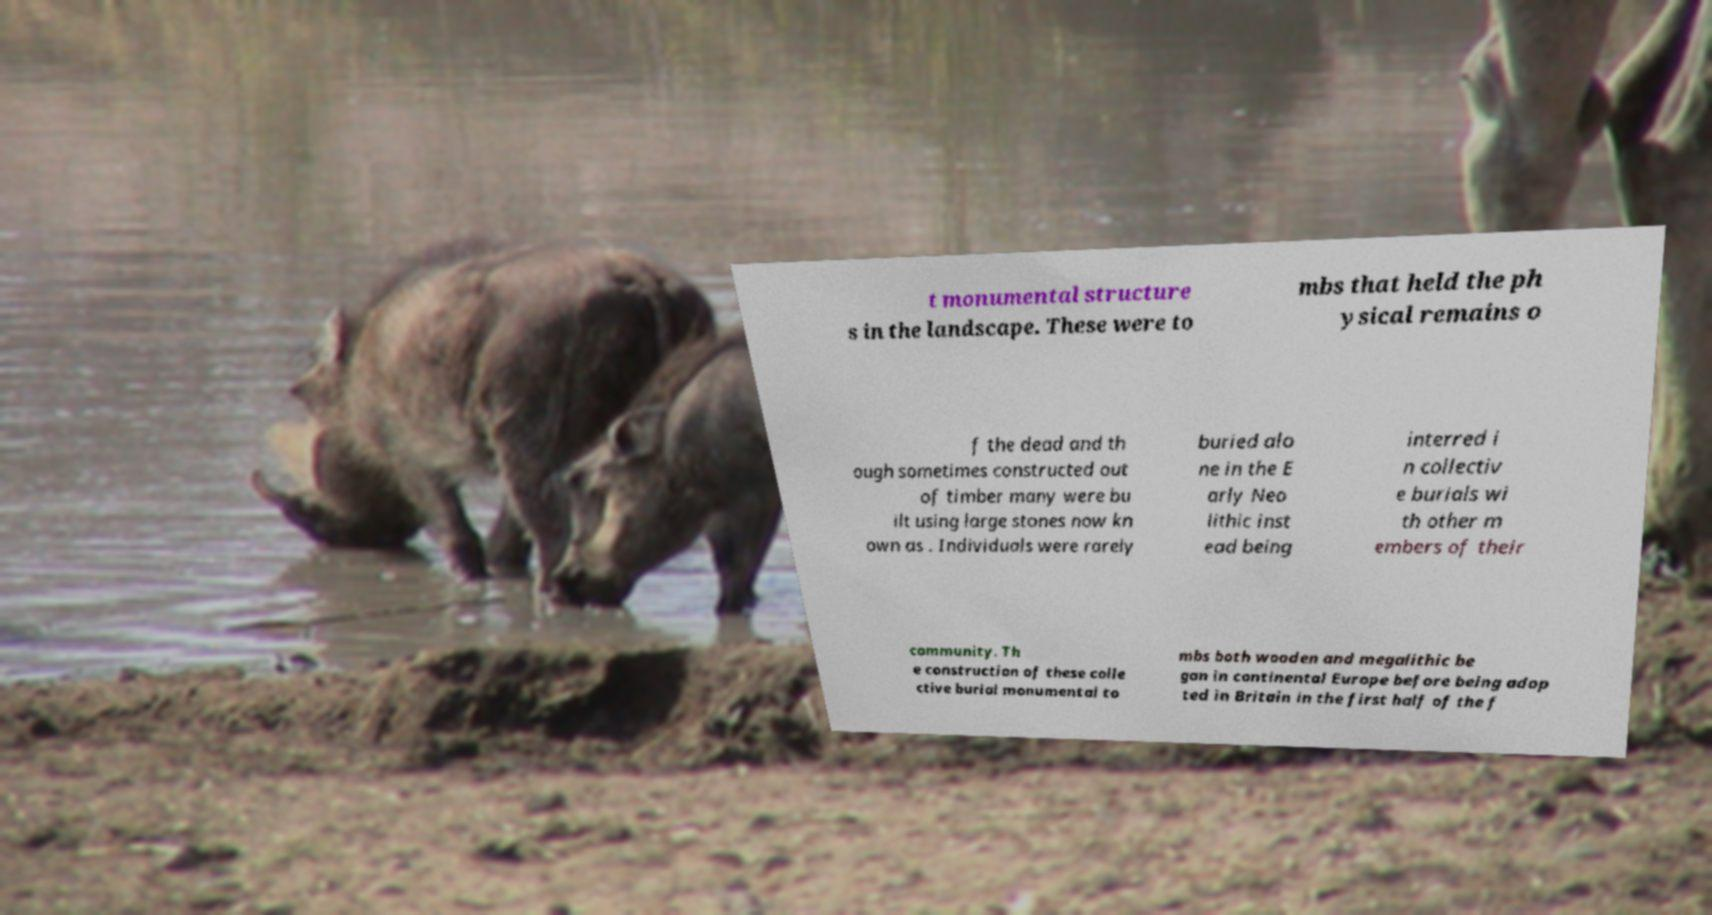Could you extract and type out the text from this image? t monumental structure s in the landscape. These were to mbs that held the ph ysical remains o f the dead and th ough sometimes constructed out of timber many were bu ilt using large stones now kn own as . Individuals were rarely buried alo ne in the E arly Neo lithic inst ead being interred i n collectiv e burials wi th other m embers of their community. Th e construction of these colle ctive burial monumental to mbs both wooden and megalithic be gan in continental Europe before being adop ted in Britain in the first half of the f 